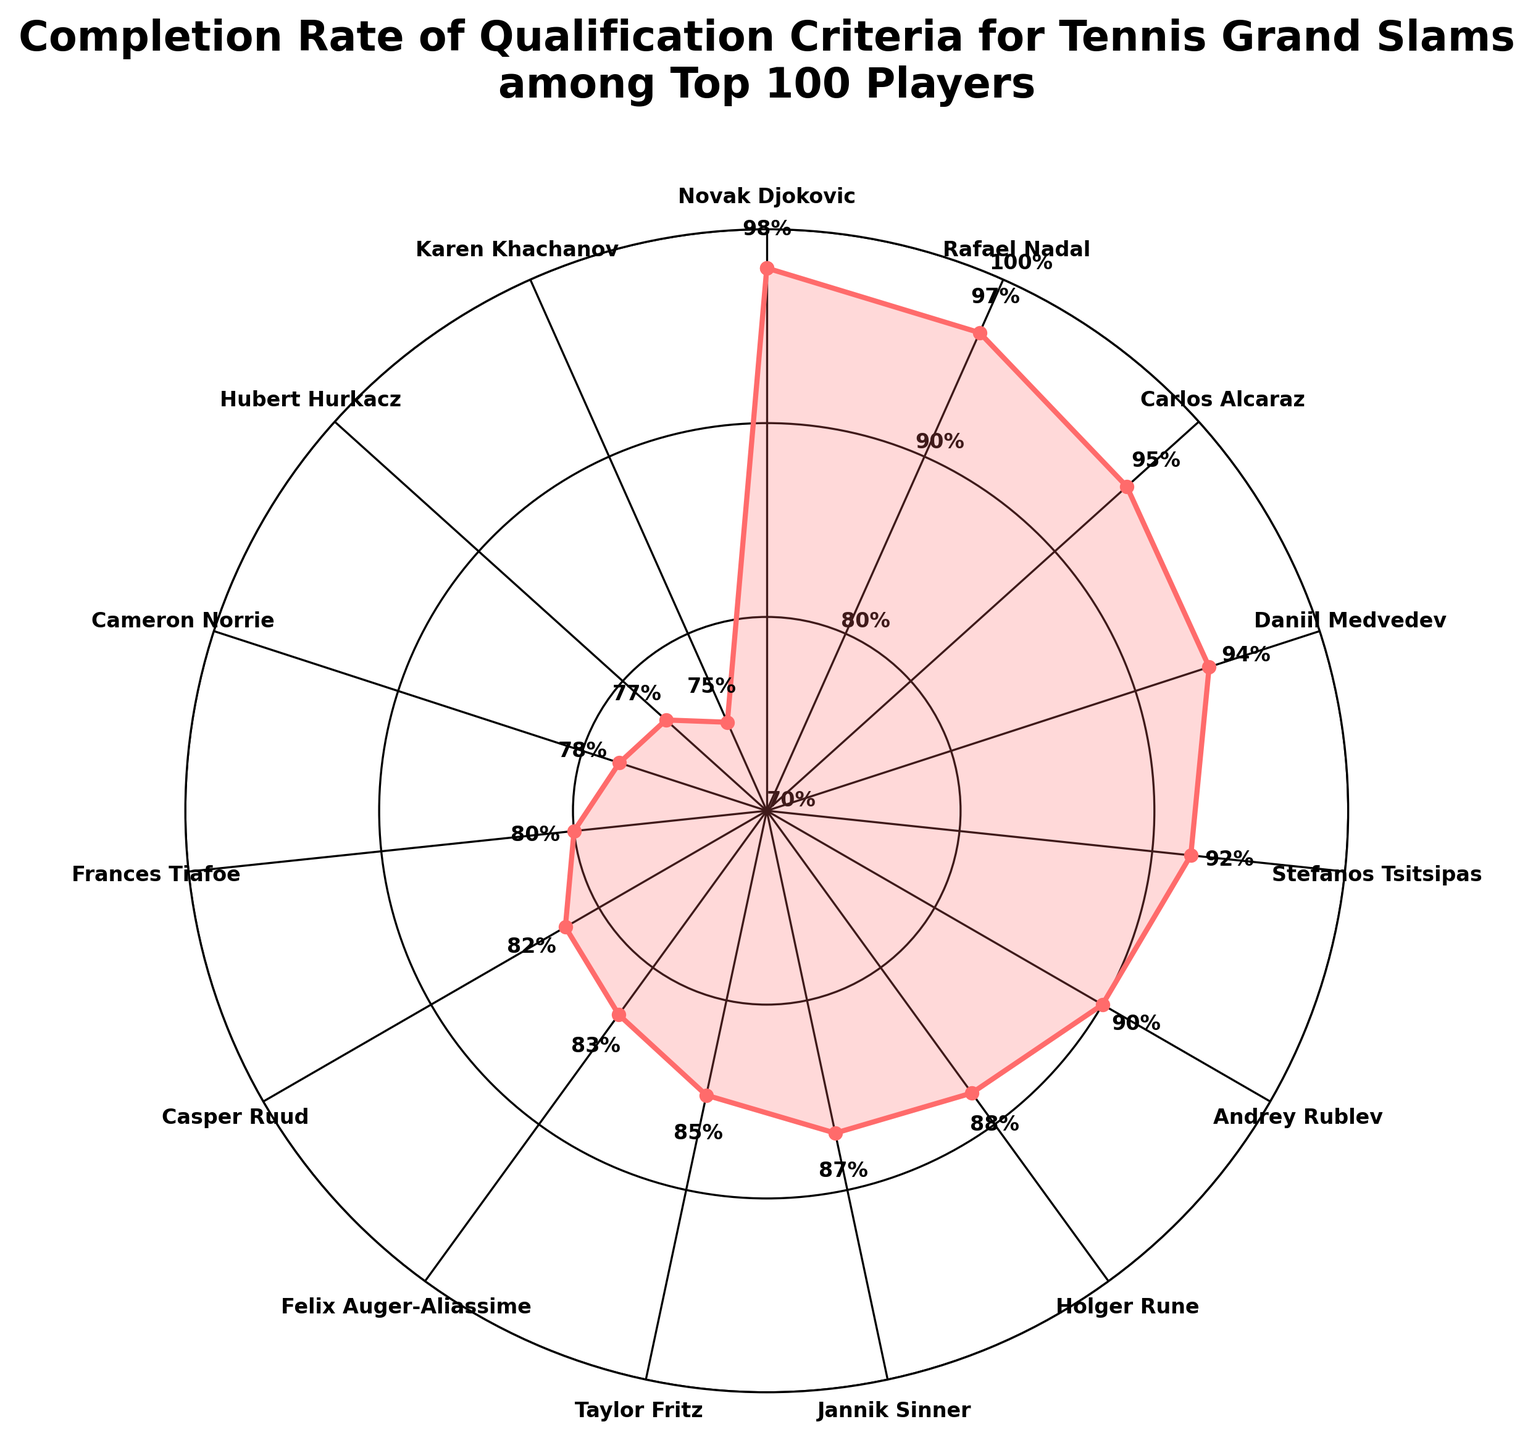How many players have a completion rate of 90% or higher? By looking at the chart, we can see the completion rates labeled near each point. There are 6 players with a completion rate of 90% or higher (Novak Djokovic, Rafael Nadal, Carlos Alcaraz, Daniil Medvedev, Stefanos Tsitsipas, and Andrey Rublev).
Answer: 6 What is the range of completion rates displayed in the chart? The range is calculated by finding the difference between the highest and lowest completion rates. The highest is Novak Djokovic with 98% and the lowest is Karen Khachanov with 75%. The range is 98% - 75% = 23%.
Answer: 23% Who has a higher completion rate, Daniil Medvedev or Jannik Sinner? Referring to the chart, Daniil Medvedev has a completion rate of 94% and Jannik Sinner has 87%.
Answer: Daniil Medvedev Is the completion rate of Rafael Nadal greater than 95%? Looking at Rafael Nadal's completion rate, it is 97%, which is greater than 95%.
Answer: Yes What is the average completion rate of the players listed in the plot? To calculate the average, sum up all the completion rates and divide by the number of players. The sum is 98 + 97 + 95 + 94 + 92 + 90 + 88 + 87 + 85 + 83 + 82 + 80 + 78 + 77 + 75 = 1301. There are 15 players, so the average is 1301 / 15 = 86.73%.
Answer: 86.73% Which player has the lowest completion rate? The chart indicates that Karen Khachanov has the lowest completion rate with 75%.
Answer: Karen Khachanov In which color gauge segment is Stefanos Tsitsipas's completion rate? Stefanos Tsitsipas has a completion rate of 92%. The gauge colors are divided as follows: red (0-25%), orange (25-50%), yellow (50-75%), green (75-100%). Since 92% falls in the green segment (75-100%), Tsitsipas's completion rate falls in the green segment.
Answer: Green What is the median completion rate among the players listed? To find the median, list the completion rates in order: 75, 77, 78, 80, 82, 83, 85, 87, 88, 90, 92, 94, 95, 97, 98. With 15 values, the median is the 8th value, which is 87%.
Answer: 87% How many players have a completion rate lower than 80%? Examining the chart, there are 4 players with a completion rate lower than 80%: Cameron Norrie, Hubert Hurkacz, Karen Khachanov, and Frances Tiafoe.
Answer: 4 